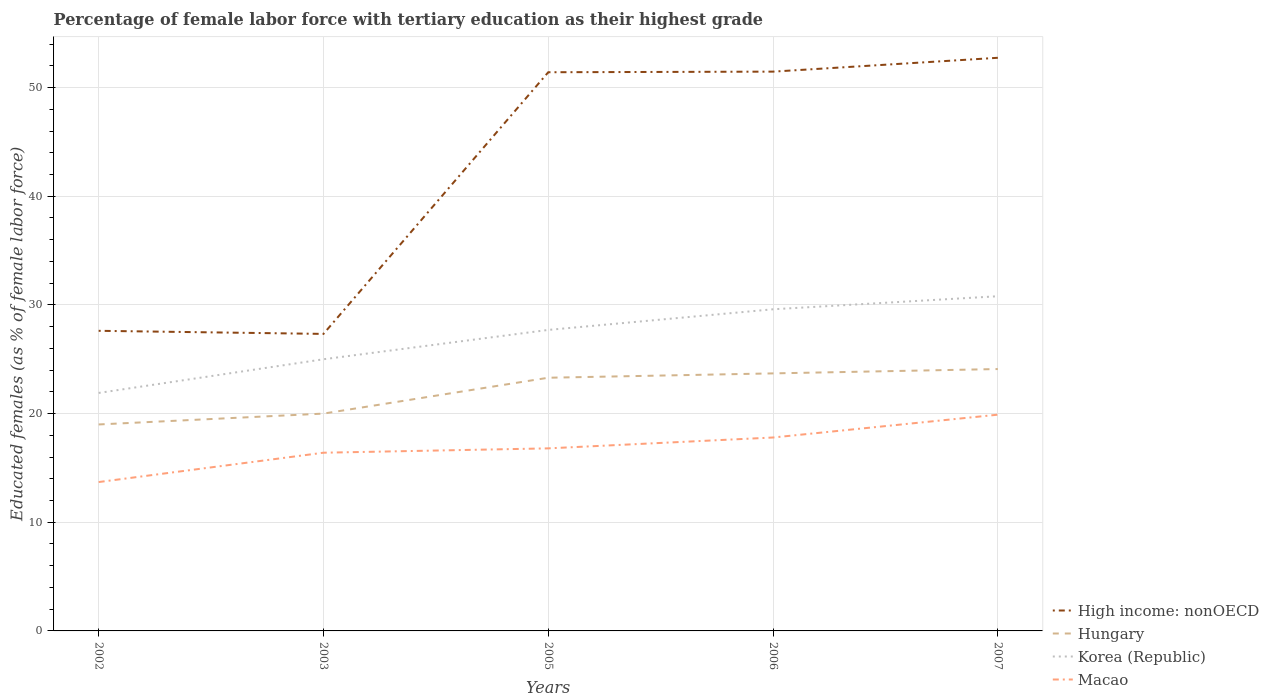How many different coloured lines are there?
Ensure brevity in your answer.  4. Does the line corresponding to Korea (Republic) intersect with the line corresponding to Macao?
Your response must be concise. No. Across all years, what is the maximum percentage of female labor force with tertiary education in High income: nonOECD?
Your response must be concise. 27.33. What is the total percentage of female labor force with tertiary education in Korea (Republic) in the graph?
Offer a very short reply. -1.2. What is the difference between the highest and the second highest percentage of female labor force with tertiary education in Korea (Republic)?
Offer a terse response. 8.9. What is the difference between the highest and the lowest percentage of female labor force with tertiary education in High income: nonOECD?
Make the answer very short. 3. How many years are there in the graph?
Offer a very short reply. 5. Are the values on the major ticks of Y-axis written in scientific E-notation?
Your response must be concise. No. Does the graph contain any zero values?
Ensure brevity in your answer.  No. Does the graph contain grids?
Your answer should be very brief. Yes. Where does the legend appear in the graph?
Keep it short and to the point. Bottom right. How many legend labels are there?
Your answer should be very brief. 4. How are the legend labels stacked?
Provide a succinct answer. Vertical. What is the title of the graph?
Keep it short and to the point. Percentage of female labor force with tertiary education as their highest grade. Does "Marshall Islands" appear as one of the legend labels in the graph?
Make the answer very short. No. What is the label or title of the X-axis?
Provide a succinct answer. Years. What is the label or title of the Y-axis?
Provide a succinct answer. Educated females (as % of female labor force). What is the Educated females (as % of female labor force) in High income: nonOECD in 2002?
Provide a succinct answer. 27.62. What is the Educated females (as % of female labor force) of Korea (Republic) in 2002?
Offer a terse response. 21.9. What is the Educated females (as % of female labor force) of Macao in 2002?
Your response must be concise. 13.7. What is the Educated females (as % of female labor force) in High income: nonOECD in 2003?
Give a very brief answer. 27.33. What is the Educated females (as % of female labor force) in Macao in 2003?
Ensure brevity in your answer.  16.4. What is the Educated females (as % of female labor force) of High income: nonOECD in 2005?
Offer a very short reply. 51.41. What is the Educated females (as % of female labor force) in Hungary in 2005?
Your response must be concise. 23.3. What is the Educated females (as % of female labor force) in Korea (Republic) in 2005?
Give a very brief answer. 27.7. What is the Educated females (as % of female labor force) in Macao in 2005?
Give a very brief answer. 16.8. What is the Educated females (as % of female labor force) in High income: nonOECD in 2006?
Make the answer very short. 51.47. What is the Educated females (as % of female labor force) of Hungary in 2006?
Offer a terse response. 23.7. What is the Educated females (as % of female labor force) of Korea (Republic) in 2006?
Give a very brief answer. 29.6. What is the Educated females (as % of female labor force) in Macao in 2006?
Provide a succinct answer. 17.8. What is the Educated females (as % of female labor force) in High income: nonOECD in 2007?
Provide a short and direct response. 52.74. What is the Educated females (as % of female labor force) in Hungary in 2007?
Your answer should be very brief. 24.1. What is the Educated females (as % of female labor force) of Korea (Republic) in 2007?
Your answer should be very brief. 30.8. What is the Educated females (as % of female labor force) of Macao in 2007?
Your answer should be compact. 19.9. Across all years, what is the maximum Educated females (as % of female labor force) of High income: nonOECD?
Make the answer very short. 52.74. Across all years, what is the maximum Educated females (as % of female labor force) of Hungary?
Your answer should be compact. 24.1. Across all years, what is the maximum Educated females (as % of female labor force) of Korea (Republic)?
Offer a terse response. 30.8. Across all years, what is the maximum Educated females (as % of female labor force) in Macao?
Your response must be concise. 19.9. Across all years, what is the minimum Educated females (as % of female labor force) in High income: nonOECD?
Offer a terse response. 27.33. Across all years, what is the minimum Educated females (as % of female labor force) in Hungary?
Your answer should be compact. 19. Across all years, what is the minimum Educated females (as % of female labor force) of Korea (Republic)?
Offer a very short reply. 21.9. Across all years, what is the minimum Educated females (as % of female labor force) of Macao?
Make the answer very short. 13.7. What is the total Educated females (as % of female labor force) in High income: nonOECD in the graph?
Your answer should be compact. 210.58. What is the total Educated females (as % of female labor force) of Hungary in the graph?
Provide a succinct answer. 110.1. What is the total Educated females (as % of female labor force) in Korea (Republic) in the graph?
Give a very brief answer. 135. What is the total Educated females (as % of female labor force) of Macao in the graph?
Ensure brevity in your answer.  84.6. What is the difference between the Educated females (as % of female labor force) in High income: nonOECD in 2002 and that in 2003?
Offer a terse response. 0.28. What is the difference between the Educated females (as % of female labor force) in Korea (Republic) in 2002 and that in 2003?
Give a very brief answer. -3.1. What is the difference between the Educated females (as % of female labor force) of High income: nonOECD in 2002 and that in 2005?
Provide a short and direct response. -23.8. What is the difference between the Educated females (as % of female labor force) in Hungary in 2002 and that in 2005?
Ensure brevity in your answer.  -4.3. What is the difference between the Educated females (as % of female labor force) of High income: nonOECD in 2002 and that in 2006?
Offer a very short reply. -23.85. What is the difference between the Educated females (as % of female labor force) in Hungary in 2002 and that in 2006?
Ensure brevity in your answer.  -4.7. What is the difference between the Educated females (as % of female labor force) of Korea (Republic) in 2002 and that in 2006?
Make the answer very short. -7.7. What is the difference between the Educated females (as % of female labor force) of Macao in 2002 and that in 2006?
Offer a terse response. -4.1. What is the difference between the Educated females (as % of female labor force) in High income: nonOECD in 2002 and that in 2007?
Your response must be concise. -25.13. What is the difference between the Educated females (as % of female labor force) of Hungary in 2002 and that in 2007?
Your answer should be very brief. -5.1. What is the difference between the Educated females (as % of female labor force) of Macao in 2002 and that in 2007?
Your answer should be very brief. -6.2. What is the difference between the Educated females (as % of female labor force) in High income: nonOECD in 2003 and that in 2005?
Offer a terse response. -24.08. What is the difference between the Educated females (as % of female labor force) in Hungary in 2003 and that in 2005?
Your answer should be very brief. -3.3. What is the difference between the Educated females (as % of female labor force) in High income: nonOECD in 2003 and that in 2006?
Your answer should be compact. -24.14. What is the difference between the Educated females (as % of female labor force) of Hungary in 2003 and that in 2006?
Ensure brevity in your answer.  -3.7. What is the difference between the Educated females (as % of female labor force) of High income: nonOECD in 2003 and that in 2007?
Provide a short and direct response. -25.41. What is the difference between the Educated females (as % of female labor force) in Hungary in 2003 and that in 2007?
Your response must be concise. -4.1. What is the difference between the Educated females (as % of female labor force) of High income: nonOECD in 2005 and that in 2006?
Give a very brief answer. -0.06. What is the difference between the Educated females (as % of female labor force) of Korea (Republic) in 2005 and that in 2006?
Your answer should be compact. -1.9. What is the difference between the Educated females (as % of female labor force) in Macao in 2005 and that in 2006?
Ensure brevity in your answer.  -1. What is the difference between the Educated females (as % of female labor force) of High income: nonOECD in 2005 and that in 2007?
Offer a terse response. -1.33. What is the difference between the Educated females (as % of female labor force) in Hungary in 2005 and that in 2007?
Your response must be concise. -0.8. What is the difference between the Educated females (as % of female labor force) in Macao in 2005 and that in 2007?
Keep it short and to the point. -3.1. What is the difference between the Educated females (as % of female labor force) in High income: nonOECD in 2006 and that in 2007?
Your answer should be very brief. -1.27. What is the difference between the Educated females (as % of female labor force) of Hungary in 2006 and that in 2007?
Provide a succinct answer. -0.4. What is the difference between the Educated females (as % of female labor force) of Macao in 2006 and that in 2007?
Keep it short and to the point. -2.1. What is the difference between the Educated females (as % of female labor force) of High income: nonOECD in 2002 and the Educated females (as % of female labor force) of Hungary in 2003?
Your answer should be very brief. 7.62. What is the difference between the Educated females (as % of female labor force) in High income: nonOECD in 2002 and the Educated females (as % of female labor force) in Korea (Republic) in 2003?
Your answer should be very brief. 2.62. What is the difference between the Educated females (as % of female labor force) in High income: nonOECD in 2002 and the Educated females (as % of female labor force) in Macao in 2003?
Ensure brevity in your answer.  11.22. What is the difference between the Educated females (as % of female labor force) of Korea (Republic) in 2002 and the Educated females (as % of female labor force) of Macao in 2003?
Provide a succinct answer. 5.5. What is the difference between the Educated females (as % of female labor force) in High income: nonOECD in 2002 and the Educated females (as % of female labor force) in Hungary in 2005?
Ensure brevity in your answer.  4.32. What is the difference between the Educated females (as % of female labor force) in High income: nonOECD in 2002 and the Educated females (as % of female labor force) in Korea (Republic) in 2005?
Provide a succinct answer. -0.08. What is the difference between the Educated females (as % of female labor force) of High income: nonOECD in 2002 and the Educated females (as % of female labor force) of Macao in 2005?
Give a very brief answer. 10.82. What is the difference between the Educated females (as % of female labor force) of Hungary in 2002 and the Educated females (as % of female labor force) of Korea (Republic) in 2005?
Ensure brevity in your answer.  -8.7. What is the difference between the Educated females (as % of female labor force) of Korea (Republic) in 2002 and the Educated females (as % of female labor force) of Macao in 2005?
Make the answer very short. 5.1. What is the difference between the Educated females (as % of female labor force) in High income: nonOECD in 2002 and the Educated females (as % of female labor force) in Hungary in 2006?
Provide a short and direct response. 3.92. What is the difference between the Educated females (as % of female labor force) of High income: nonOECD in 2002 and the Educated females (as % of female labor force) of Korea (Republic) in 2006?
Offer a terse response. -1.98. What is the difference between the Educated females (as % of female labor force) in High income: nonOECD in 2002 and the Educated females (as % of female labor force) in Macao in 2006?
Your answer should be compact. 9.82. What is the difference between the Educated females (as % of female labor force) of Hungary in 2002 and the Educated females (as % of female labor force) of Korea (Republic) in 2006?
Provide a succinct answer. -10.6. What is the difference between the Educated females (as % of female labor force) of High income: nonOECD in 2002 and the Educated females (as % of female labor force) of Hungary in 2007?
Make the answer very short. 3.52. What is the difference between the Educated females (as % of female labor force) in High income: nonOECD in 2002 and the Educated females (as % of female labor force) in Korea (Republic) in 2007?
Make the answer very short. -3.18. What is the difference between the Educated females (as % of female labor force) in High income: nonOECD in 2002 and the Educated females (as % of female labor force) in Macao in 2007?
Your answer should be compact. 7.72. What is the difference between the Educated females (as % of female labor force) in Hungary in 2002 and the Educated females (as % of female labor force) in Korea (Republic) in 2007?
Make the answer very short. -11.8. What is the difference between the Educated females (as % of female labor force) in Korea (Republic) in 2002 and the Educated females (as % of female labor force) in Macao in 2007?
Ensure brevity in your answer.  2. What is the difference between the Educated females (as % of female labor force) of High income: nonOECD in 2003 and the Educated females (as % of female labor force) of Hungary in 2005?
Offer a terse response. 4.03. What is the difference between the Educated females (as % of female labor force) of High income: nonOECD in 2003 and the Educated females (as % of female labor force) of Korea (Republic) in 2005?
Your answer should be very brief. -0.37. What is the difference between the Educated females (as % of female labor force) of High income: nonOECD in 2003 and the Educated females (as % of female labor force) of Macao in 2005?
Ensure brevity in your answer.  10.53. What is the difference between the Educated females (as % of female labor force) of High income: nonOECD in 2003 and the Educated females (as % of female labor force) of Hungary in 2006?
Ensure brevity in your answer.  3.63. What is the difference between the Educated females (as % of female labor force) of High income: nonOECD in 2003 and the Educated females (as % of female labor force) of Korea (Republic) in 2006?
Keep it short and to the point. -2.27. What is the difference between the Educated females (as % of female labor force) in High income: nonOECD in 2003 and the Educated females (as % of female labor force) in Macao in 2006?
Give a very brief answer. 9.53. What is the difference between the Educated females (as % of female labor force) in Hungary in 2003 and the Educated females (as % of female labor force) in Korea (Republic) in 2006?
Offer a very short reply. -9.6. What is the difference between the Educated females (as % of female labor force) in Hungary in 2003 and the Educated females (as % of female labor force) in Macao in 2006?
Ensure brevity in your answer.  2.2. What is the difference between the Educated females (as % of female labor force) of Korea (Republic) in 2003 and the Educated females (as % of female labor force) of Macao in 2006?
Offer a very short reply. 7.2. What is the difference between the Educated females (as % of female labor force) in High income: nonOECD in 2003 and the Educated females (as % of female labor force) in Hungary in 2007?
Provide a short and direct response. 3.23. What is the difference between the Educated females (as % of female labor force) in High income: nonOECD in 2003 and the Educated females (as % of female labor force) in Korea (Republic) in 2007?
Keep it short and to the point. -3.47. What is the difference between the Educated females (as % of female labor force) of High income: nonOECD in 2003 and the Educated females (as % of female labor force) of Macao in 2007?
Provide a succinct answer. 7.43. What is the difference between the Educated females (as % of female labor force) of High income: nonOECD in 2005 and the Educated females (as % of female labor force) of Hungary in 2006?
Provide a short and direct response. 27.71. What is the difference between the Educated females (as % of female labor force) in High income: nonOECD in 2005 and the Educated females (as % of female labor force) in Korea (Republic) in 2006?
Ensure brevity in your answer.  21.81. What is the difference between the Educated females (as % of female labor force) of High income: nonOECD in 2005 and the Educated females (as % of female labor force) of Macao in 2006?
Make the answer very short. 33.61. What is the difference between the Educated females (as % of female labor force) in Hungary in 2005 and the Educated females (as % of female labor force) in Macao in 2006?
Keep it short and to the point. 5.5. What is the difference between the Educated females (as % of female labor force) of Korea (Republic) in 2005 and the Educated females (as % of female labor force) of Macao in 2006?
Offer a very short reply. 9.9. What is the difference between the Educated females (as % of female labor force) of High income: nonOECD in 2005 and the Educated females (as % of female labor force) of Hungary in 2007?
Offer a very short reply. 27.31. What is the difference between the Educated females (as % of female labor force) in High income: nonOECD in 2005 and the Educated females (as % of female labor force) in Korea (Republic) in 2007?
Your response must be concise. 20.61. What is the difference between the Educated females (as % of female labor force) of High income: nonOECD in 2005 and the Educated females (as % of female labor force) of Macao in 2007?
Keep it short and to the point. 31.51. What is the difference between the Educated females (as % of female labor force) of Hungary in 2005 and the Educated females (as % of female labor force) of Macao in 2007?
Give a very brief answer. 3.4. What is the difference between the Educated females (as % of female labor force) in High income: nonOECD in 2006 and the Educated females (as % of female labor force) in Hungary in 2007?
Keep it short and to the point. 27.37. What is the difference between the Educated females (as % of female labor force) of High income: nonOECD in 2006 and the Educated females (as % of female labor force) of Korea (Republic) in 2007?
Offer a very short reply. 20.67. What is the difference between the Educated females (as % of female labor force) of High income: nonOECD in 2006 and the Educated females (as % of female labor force) of Macao in 2007?
Offer a very short reply. 31.57. What is the difference between the Educated females (as % of female labor force) in Hungary in 2006 and the Educated females (as % of female labor force) in Korea (Republic) in 2007?
Offer a terse response. -7.1. What is the difference between the Educated females (as % of female labor force) of Hungary in 2006 and the Educated females (as % of female labor force) of Macao in 2007?
Ensure brevity in your answer.  3.8. What is the average Educated females (as % of female labor force) in High income: nonOECD per year?
Offer a very short reply. 42.12. What is the average Educated females (as % of female labor force) in Hungary per year?
Give a very brief answer. 22.02. What is the average Educated females (as % of female labor force) in Korea (Republic) per year?
Offer a very short reply. 27. What is the average Educated females (as % of female labor force) of Macao per year?
Your answer should be compact. 16.92. In the year 2002, what is the difference between the Educated females (as % of female labor force) of High income: nonOECD and Educated females (as % of female labor force) of Hungary?
Provide a succinct answer. 8.62. In the year 2002, what is the difference between the Educated females (as % of female labor force) of High income: nonOECD and Educated females (as % of female labor force) of Korea (Republic)?
Offer a terse response. 5.72. In the year 2002, what is the difference between the Educated females (as % of female labor force) of High income: nonOECD and Educated females (as % of female labor force) of Macao?
Keep it short and to the point. 13.92. In the year 2002, what is the difference between the Educated females (as % of female labor force) of Hungary and Educated females (as % of female labor force) of Korea (Republic)?
Your answer should be very brief. -2.9. In the year 2003, what is the difference between the Educated females (as % of female labor force) in High income: nonOECD and Educated females (as % of female labor force) in Hungary?
Make the answer very short. 7.33. In the year 2003, what is the difference between the Educated females (as % of female labor force) of High income: nonOECD and Educated females (as % of female labor force) of Korea (Republic)?
Provide a succinct answer. 2.33. In the year 2003, what is the difference between the Educated females (as % of female labor force) of High income: nonOECD and Educated females (as % of female labor force) of Macao?
Your answer should be compact. 10.93. In the year 2003, what is the difference between the Educated females (as % of female labor force) in Hungary and Educated females (as % of female labor force) in Korea (Republic)?
Your answer should be very brief. -5. In the year 2003, what is the difference between the Educated females (as % of female labor force) in Korea (Republic) and Educated females (as % of female labor force) in Macao?
Provide a short and direct response. 8.6. In the year 2005, what is the difference between the Educated females (as % of female labor force) in High income: nonOECD and Educated females (as % of female labor force) in Hungary?
Provide a succinct answer. 28.11. In the year 2005, what is the difference between the Educated females (as % of female labor force) of High income: nonOECD and Educated females (as % of female labor force) of Korea (Republic)?
Offer a very short reply. 23.71. In the year 2005, what is the difference between the Educated females (as % of female labor force) of High income: nonOECD and Educated females (as % of female labor force) of Macao?
Your response must be concise. 34.61. In the year 2005, what is the difference between the Educated females (as % of female labor force) in Hungary and Educated females (as % of female labor force) in Korea (Republic)?
Give a very brief answer. -4.4. In the year 2005, what is the difference between the Educated females (as % of female labor force) of Hungary and Educated females (as % of female labor force) of Macao?
Your answer should be compact. 6.5. In the year 2006, what is the difference between the Educated females (as % of female labor force) of High income: nonOECD and Educated females (as % of female labor force) of Hungary?
Offer a terse response. 27.77. In the year 2006, what is the difference between the Educated females (as % of female labor force) in High income: nonOECD and Educated females (as % of female labor force) in Korea (Republic)?
Ensure brevity in your answer.  21.87. In the year 2006, what is the difference between the Educated females (as % of female labor force) of High income: nonOECD and Educated females (as % of female labor force) of Macao?
Give a very brief answer. 33.67. In the year 2006, what is the difference between the Educated females (as % of female labor force) of Hungary and Educated females (as % of female labor force) of Korea (Republic)?
Make the answer very short. -5.9. In the year 2006, what is the difference between the Educated females (as % of female labor force) in Hungary and Educated females (as % of female labor force) in Macao?
Offer a terse response. 5.9. In the year 2007, what is the difference between the Educated females (as % of female labor force) of High income: nonOECD and Educated females (as % of female labor force) of Hungary?
Offer a terse response. 28.64. In the year 2007, what is the difference between the Educated females (as % of female labor force) in High income: nonOECD and Educated females (as % of female labor force) in Korea (Republic)?
Provide a short and direct response. 21.94. In the year 2007, what is the difference between the Educated females (as % of female labor force) in High income: nonOECD and Educated females (as % of female labor force) in Macao?
Keep it short and to the point. 32.84. In the year 2007, what is the difference between the Educated females (as % of female labor force) of Korea (Republic) and Educated females (as % of female labor force) of Macao?
Keep it short and to the point. 10.9. What is the ratio of the Educated females (as % of female labor force) of High income: nonOECD in 2002 to that in 2003?
Keep it short and to the point. 1.01. What is the ratio of the Educated females (as % of female labor force) of Hungary in 2002 to that in 2003?
Keep it short and to the point. 0.95. What is the ratio of the Educated females (as % of female labor force) of Korea (Republic) in 2002 to that in 2003?
Your response must be concise. 0.88. What is the ratio of the Educated females (as % of female labor force) of Macao in 2002 to that in 2003?
Ensure brevity in your answer.  0.84. What is the ratio of the Educated females (as % of female labor force) of High income: nonOECD in 2002 to that in 2005?
Keep it short and to the point. 0.54. What is the ratio of the Educated females (as % of female labor force) of Hungary in 2002 to that in 2005?
Offer a terse response. 0.82. What is the ratio of the Educated females (as % of female labor force) of Korea (Republic) in 2002 to that in 2005?
Ensure brevity in your answer.  0.79. What is the ratio of the Educated females (as % of female labor force) in Macao in 2002 to that in 2005?
Ensure brevity in your answer.  0.82. What is the ratio of the Educated females (as % of female labor force) of High income: nonOECD in 2002 to that in 2006?
Offer a terse response. 0.54. What is the ratio of the Educated females (as % of female labor force) of Hungary in 2002 to that in 2006?
Provide a short and direct response. 0.8. What is the ratio of the Educated females (as % of female labor force) of Korea (Republic) in 2002 to that in 2006?
Make the answer very short. 0.74. What is the ratio of the Educated females (as % of female labor force) in Macao in 2002 to that in 2006?
Your response must be concise. 0.77. What is the ratio of the Educated females (as % of female labor force) in High income: nonOECD in 2002 to that in 2007?
Ensure brevity in your answer.  0.52. What is the ratio of the Educated females (as % of female labor force) in Hungary in 2002 to that in 2007?
Provide a succinct answer. 0.79. What is the ratio of the Educated females (as % of female labor force) of Korea (Republic) in 2002 to that in 2007?
Offer a very short reply. 0.71. What is the ratio of the Educated females (as % of female labor force) in Macao in 2002 to that in 2007?
Keep it short and to the point. 0.69. What is the ratio of the Educated females (as % of female labor force) in High income: nonOECD in 2003 to that in 2005?
Ensure brevity in your answer.  0.53. What is the ratio of the Educated females (as % of female labor force) of Hungary in 2003 to that in 2005?
Give a very brief answer. 0.86. What is the ratio of the Educated females (as % of female labor force) of Korea (Republic) in 2003 to that in 2005?
Give a very brief answer. 0.9. What is the ratio of the Educated females (as % of female labor force) of Macao in 2003 to that in 2005?
Provide a succinct answer. 0.98. What is the ratio of the Educated females (as % of female labor force) in High income: nonOECD in 2003 to that in 2006?
Your response must be concise. 0.53. What is the ratio of the Educated females (as % of female labor force) of Hungary in 2003 to that in 2006?
Your response must be concise. 0.84. What is the ratio of the Educated females (as % of female labor force) of Korea (Republic) in 2003 to that in 2006?
Give a very brief answer. 0.84. What is the ratio of the Educated females (as % of female labor force) of Macao in 2003 to that in 2006?
Keep it short and to the point. 0.92. What is the ratio of the Educated females (as % of female labor force) of High income: nonOECD in 2003 to that in 2007?
Your response must be concise. 0.52. What is the ratio of the Educated females (as % of female labor force) of Hungary in 2003 to that in 2007?
Provide a short and direct response. 0.83. What is the ratio of the Educated females (as % of female labor force) of Korea (Republic) in 2003 to that in 2007?
Make the answer very short. 0.81. What is the ratio of the Educated females (as % of female labor force) of Macao in 2003 to that in 2007?
Offer a very short reply. 0.82. What is the ratio of the Educated females (as % of female labor force) in Hungary in 2005 to that in 2006?
Provide a short and direct response. 0.98. What is the ratio of the Educated females (as % of female labor force) of Korea (Republic) in 2005 to that in 2006?
Provide a succinct answer. 0.94. What is the ratio of the Educated females (as % of female labor force) in Macao in 2005 to that in 2006?
Provide a succinct answer. 0.94. What is the ratio of the Educated females (as % of female labor force) in High income: nonOECD in 2005 to that in 2007?
Your answer should be very brief. 0.97. What is the ratio of the Educated females (as % of female labor force) in Hungary in 2005 to that in 2007?
Offer a terse response. 0.97. What is the ratio of the Educated females (as % of female labor force) in Korea (Republic) in 2005 to that in 2007?
Give a very brief answer. 0.9. What is the ratio of the Educated females (as % of female labor force) of Macao in 2005 to that in 2007?
Your response must be concise. 0.84. What is the ratio of the Educated females (as % of female labor force) of High income: nonOECD in 2006 to that in 2007?
Your answer should be very brief. 0.98. What is the ratio of the Educated females (as % of female labor force) in Hungary in 2006 to that in 2007?
Your answer should be very brief. 0.98. What is the ratio of the Educated females (as % of female labor force) of Macao in 2006 to that in 2007?
Keep it short and to the point. 0.89. What is the difference between the highest and the second highest Educated females (as % of female labor force) of High income: nonOECD?
Give a very brief answer. 1.27. What is the difference between the highest and the second highest Educated females (as % of female labor force) of Hungary?
Provide a succinct answer. 0.4. What is the difference between the highest and the second highest Educated females (as % of female labor force) in Korea (Republic)?
Keep it short and to the point. 1.2. What is the difference between the highest and the second highest Educated females (as % of female labor force) of Macao?
Provide a short and direct response. 2.1. What is the difference between the highest and the lowest Educated females (as % of female labor force) in High income: nonOECD?
Your response must be concise. 25.41. What is the difference between the highest and the lowest Educated females (as % of female labor force) in Macao?
Ensure brevity in your answer.  6.2. 